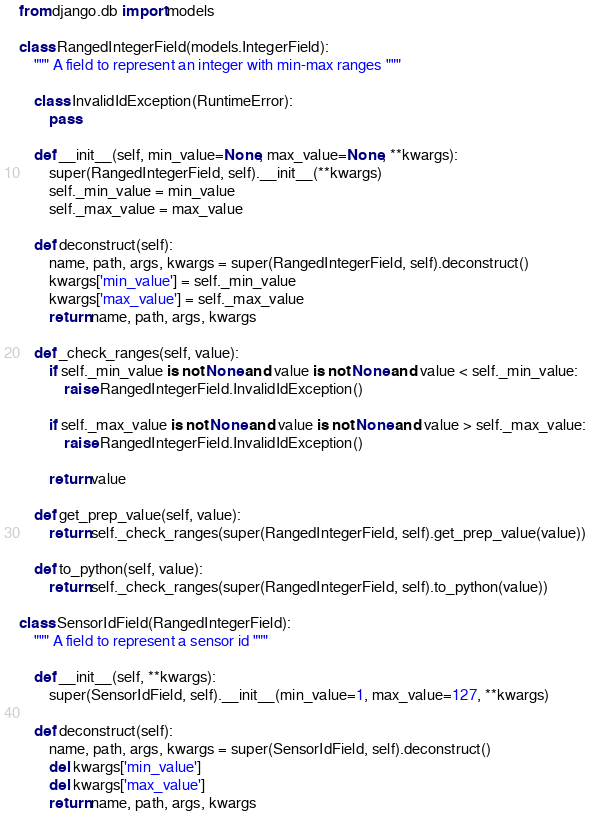Convert code to text. <code><loc_0><loc_0><loc_500><loc_500><_Python_>from django.db import models

class RangedIntegerField(models.IntegerField):
    """ A field to represent an integer with min-max ranges """

    class InvalidIdException(RuntimeError):
        pass

    def __init__(self, min_value=None, max_value=None, **kwargs):
        super(RangedIntegerField, self).__init__(**kwargs)
        self._min_value = min_value
        self._max_value = max_value

    def deconstruct(self):
        name, path, args, kwargs = super(RangedIntegerField, self).deconstruct()
        kwargs['min_value'] = self._min_value
        kwargs['max_value'] = self._max_value
        return name, path, args, kwargs

    def _check_ranges(self, value):
        if self._min_value is not None and value is not None and value < self._min_value:
            raise RangedIntegerField.InvalidIdException()

        if self._max_value is not None and value is not None and value > self._max_value:
            raise RangedIntegerField.InvalidIdException()

        return value

    def get_prep_value(self, value):
        return self._check_ranges(super(RangedIntegerField, self).get_prep_value(value))

    def to_python(self, value):
        return self._check_ranges(super(RangedIntegerField, self).to_python(value))

class SensorIdField(RangedIntegerField):
    """ A field to represent a sensor id """

    def __init__(self, **kwargs):
        super(SensorIdField, self).__init__(min_value=1, max_value=127, **kwargs)

    def deconstruct(self):
        name, path, args, kwargs = super(SensorIdField, self).deconstruct()
        del kwargs['min_value']
        del kwargs['max_value']
        return name, path, args, kwargs
</code> 